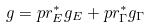<formula> <loc_0><loc_0><loc_500><loc_500>g = p r ^ { * } _ { E } g _ { E } + p r _ { \Gamma } ^ { * } g _ { \Gamma }</formula> 